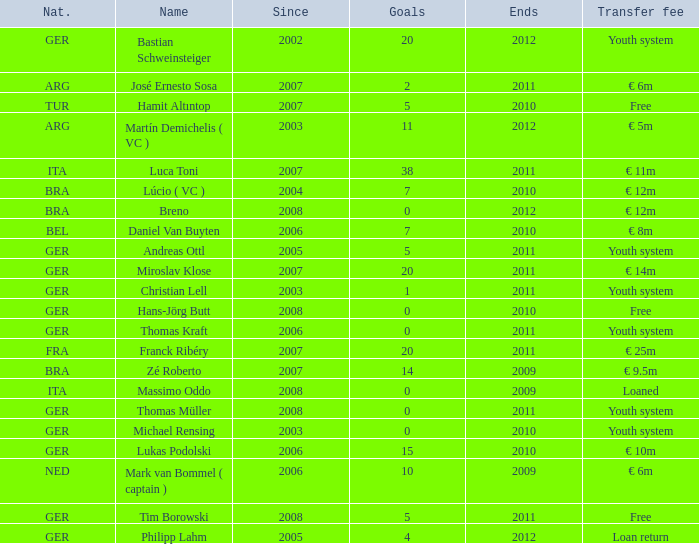What is the lowest year in since that had a transfer fee of € 14m and ended after 2011? None. 